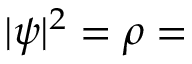<formula> <loc_0><loc_0><loc_500><loc_500>| \psi | ^ { 2 } = \rho =</formula> 